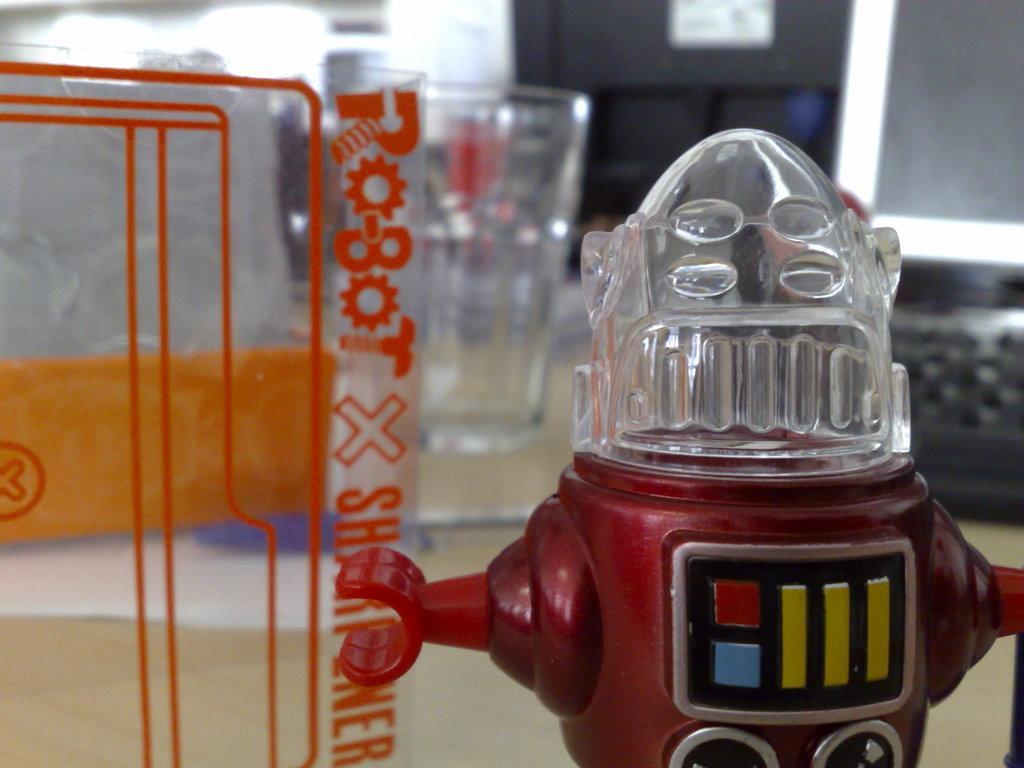<image>
Present a compact description of the photo's key features. a toy in front of a box reading robot x sharpener 